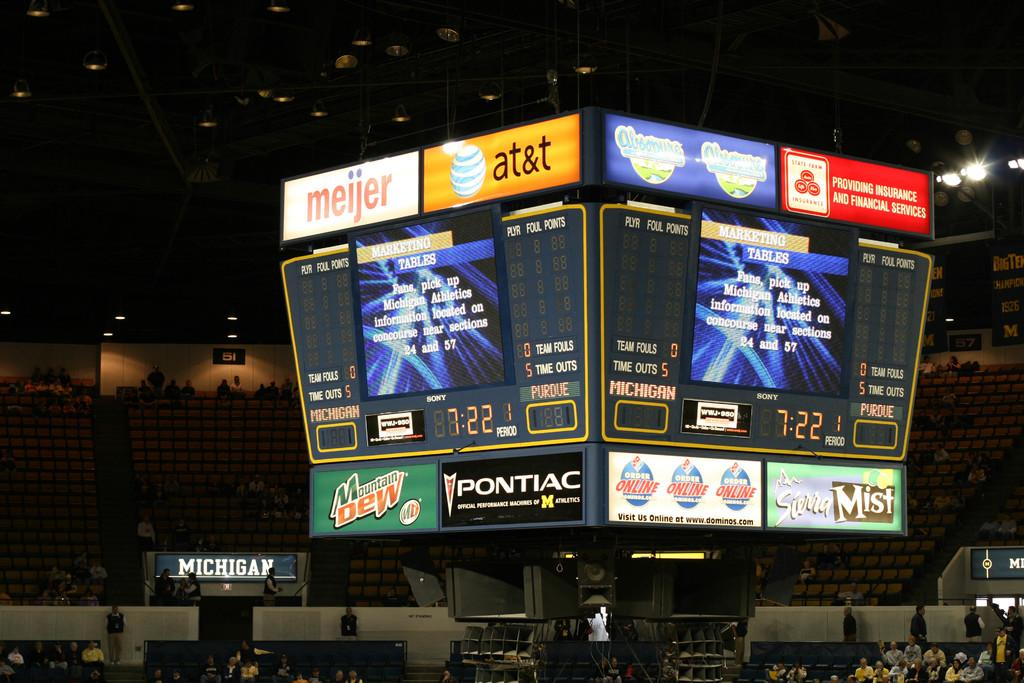<image>
Offer a succinct explanation of the picture presented. A large indoor scoreboard for a game between Michigan and Purdue. 